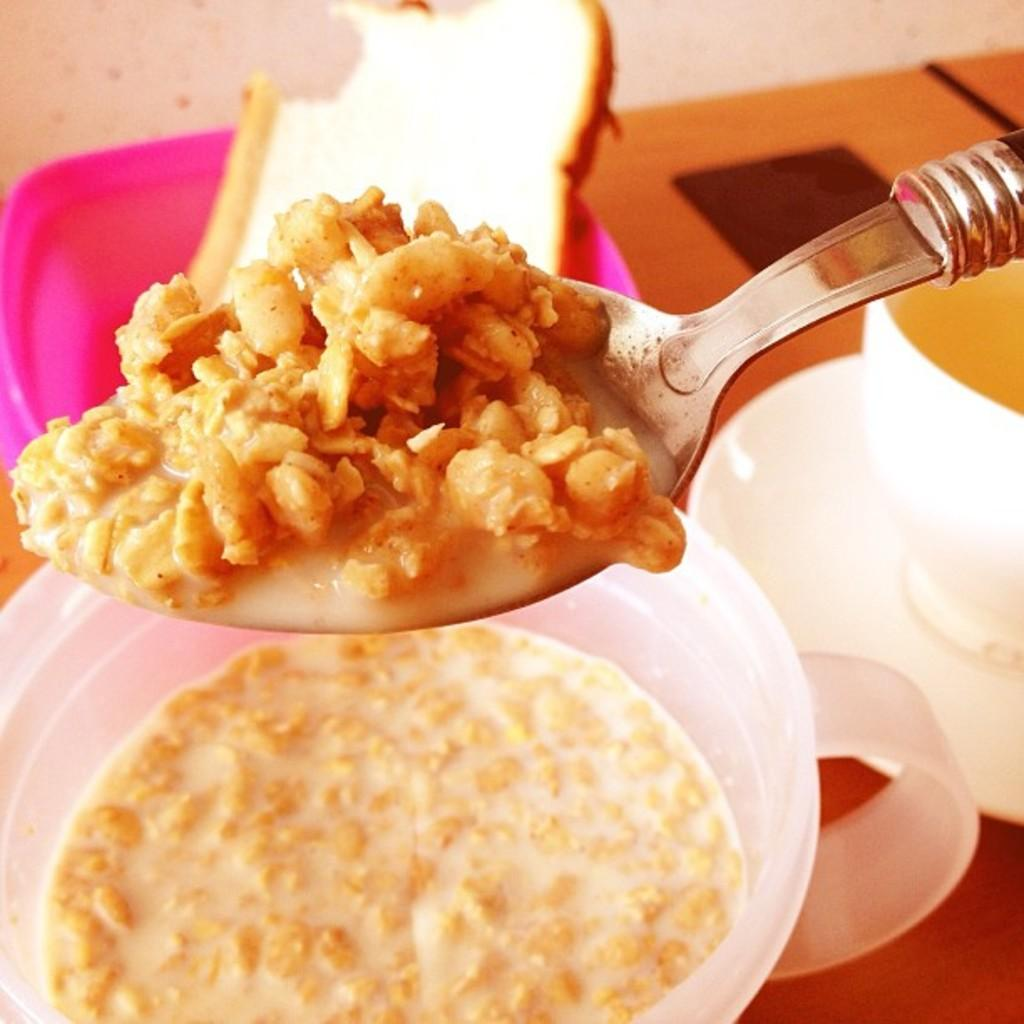What piece of furniture is present in the image? There is a table in the image. What is placed on the table? There is a cup, a saucer, a bowl, a spoon, bread, and a box on the table. What type of food item is on the table? There is a food item on the table. Who is the owner of the pin in the image? There is no pin present in the image. 